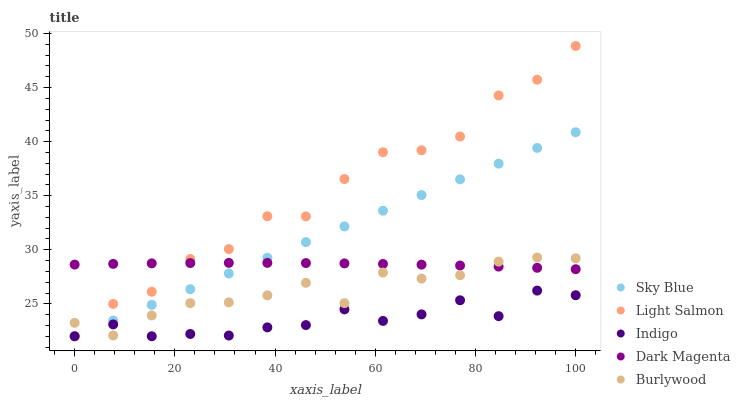Does Indigo have the minimum area under the curve?
Answer yes or no. Yes. Does Light Salmon have the maximum area under the curve?
Answer yes or no. Yes. Does Sky Blue have the minimum area under the curve?
Answer yes or no. No. Does Sky Blue have the maximum area under the curve?
Answer yes or no. No. Is Sky Blue the smoothest?
Answer yes or no. Yes. Is Light Salmon the roughest?
Answer yes or no. Yes. Is Light Salmon the smoothest?
Answer yes or no. No. Is Sky Blue the roughest?
Answer yes or no. No. Does Sky Blue have the lowest value?
Answer yes or no. Yes. Does Dark Magenta have the lowest value?
Answer yes or no. No. Does Light Salmon have the highest value?
Answer yes or no. Yes. Does Sky Blue have the highest value?
Answer yes or no. No. Is Indigo less than Dark Magenta?
Answer yes or no. Yes. Is Dark Magenta greater than Indigo?
Answer yes or no. Yes. Does Burlywood intersect Light Salmon?
Answer yes or no. Yes. Is Burlywood less than Light Salmon?
Answer yes or no. No. Is Burlywood greater than Light Salmon?
Answer yes or no. No. Does Indigo intersect Dark Magenta?
Answer yes or no. No. 